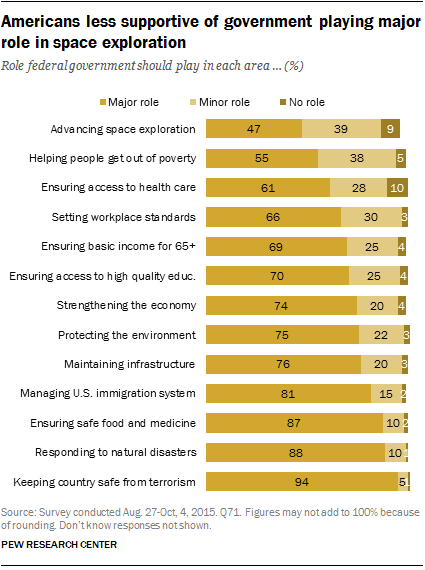Draw attention to some important aspects in this diagram. The mode of the set {3, 4} is 3. The median percentages of the major role opinion and the minor role opinion have been added. 